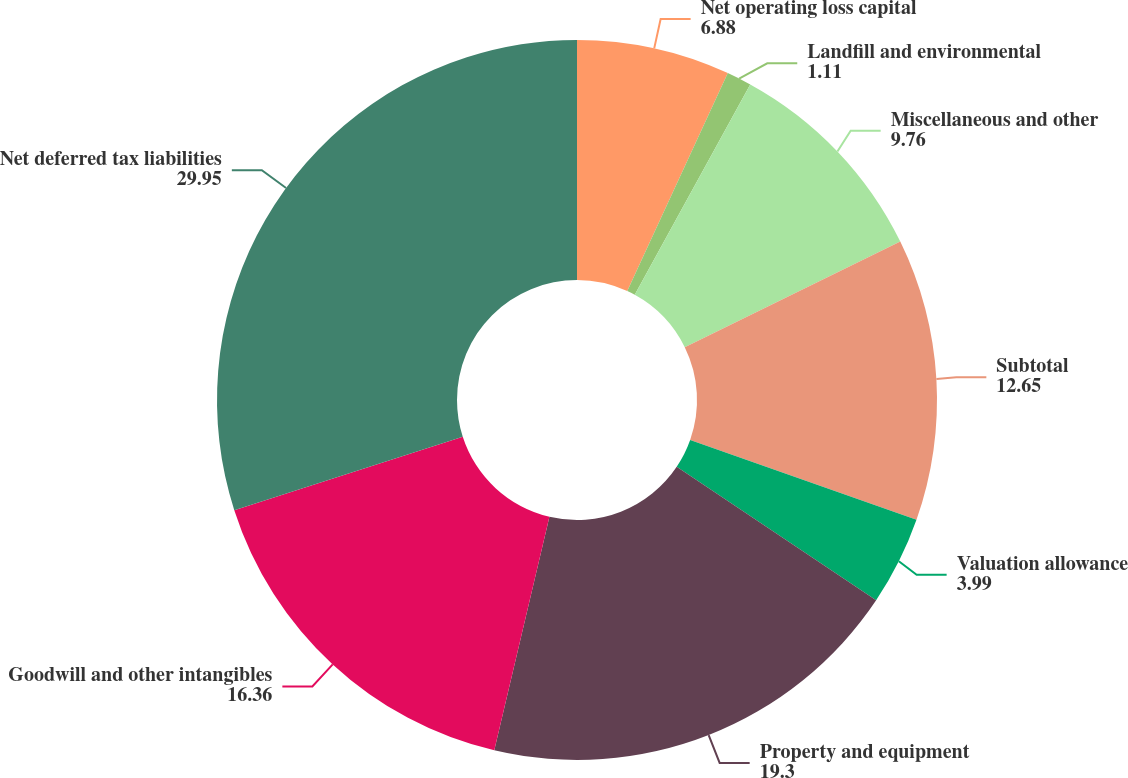Convert chart. <chart><loc_0><loc_0><loc_500><loc_500><pie_chart><fcel>Net operating loss capital<fcel>Landfill and environmental<fcel>Miscellaneous and other<fcel>Subtotal<fcel>Valuation allowance<fcel>Property and equipment<fcel>Goodwill and other intangibles<fcel>Net deferred tax liabilities<nl><fcel>6.88%<fcel>1.11%<fcel>9.76%<fcel>12.65%<fcel>3.99%<fcel>19.3%<fcel>16.36%<fcel>29.95%<nl></chart> 